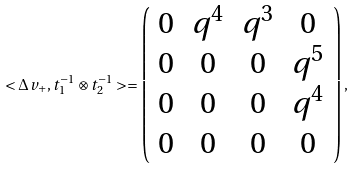Convert formula to latex. <formula><loc_0><loc_0><loc_500><loc_500>< \Delta v _ { + } , t _ { 1 } ^ { - 1 } \otimes t _ { 2 } ^ { - 1 } > = \left ( \begin{array} { c c c c } 0 & q ^ { 4 } & q ^ { 3 } & 0 \\ 0 & 0 & 0 & q ^ { 5 } \\ 0 & 0 & 0 & q ^ { 4 } \\ 0 & 0 & 0 & 0 \end{array} \right ) ,</formula> 